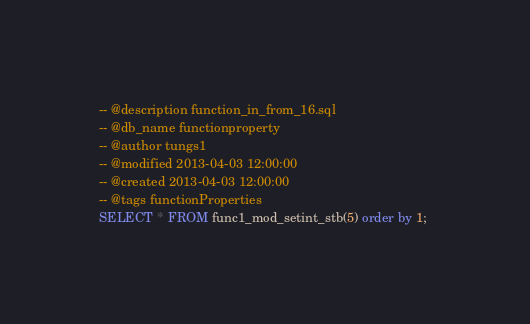Convert code to text. <code><loc_0><loc_0><loc_500><loc_500><_SQL_>-- @description function_in_from_16.sql
-- @db_name functionproperty
-- @author tungs1
-- @modified 2013-04-03 12:00:00
-- @created 2013-04-03 12:00:00
-- @tags functionProperties 
SELECT * FROM func1_mod_setint_stb(5) order by 1; 
</code> 